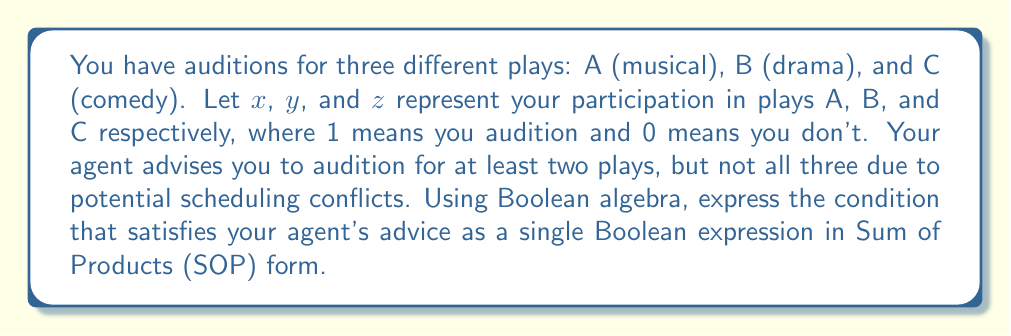Could you help me with this problem? Let's approach this step-by-step:

1) We need to represent the condition "at least two plays, but not all three".

2) In Boolean terms, this means:
   (x AND y AND NOT z) OR (x AND NOT y AND z) OR (NOT x AND y AND z)

3) We can represent this using Boolean algebra notation:
   $$(x \cdot y \cdot \overline{z}) + (x \cdot \overline{y} \cdot z) + (\overline{x} \cdot y \cdot z)$$

4) This expression is already in Sum of Products (SOP) form, as it's a sum (OR) of products (AND) of variables or their complements.

5) To verify:
   - $(x \cdot y \cdot \overline{z})$ represents auditioning for A and B but not C
   - $(x \cdot \overline{y} \cdot z)$ represents auditioning for A and C but not B
   - $(\overline{x} \cdot y \cdot z)$ represents auditioning for B and C but not A

6) This expression excludes $(x \cdot y \cdot z)$, which would represent auditioning for all three plays, satisfying the "not all three" condition.

Therefore, the Boolean expression $$(x \cdot y \cdot \overline{z}) + (x \cdot \overline{y} \cdot z) + (\overline{x} \cdot y \cdot z)$$ correctly represents the desired audition scheduling condition.
Answer: $$(x \cdot y \cdot \overline{z}) + (x \cdot \overline{y} \cdot z) + (\overline{x} \cdot y \cdot z)$$ 